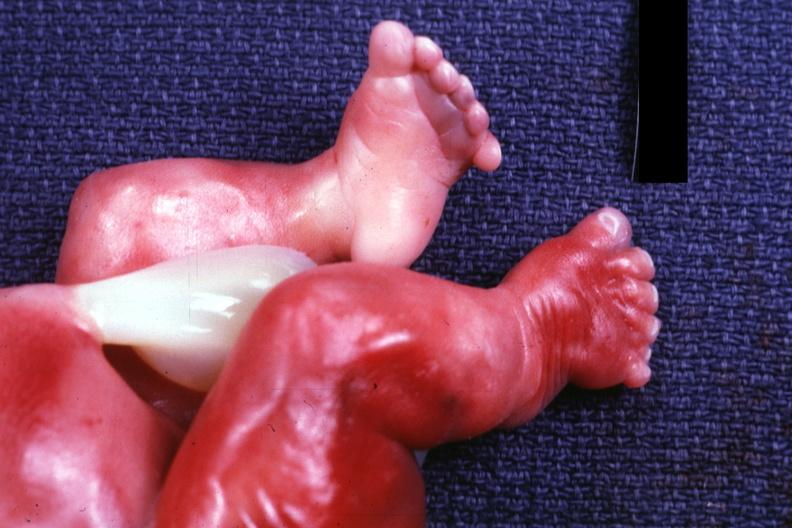does this image show newborn with renal polycystic disease legs are too short?
Answer the question using a single word or phrase. Yes 